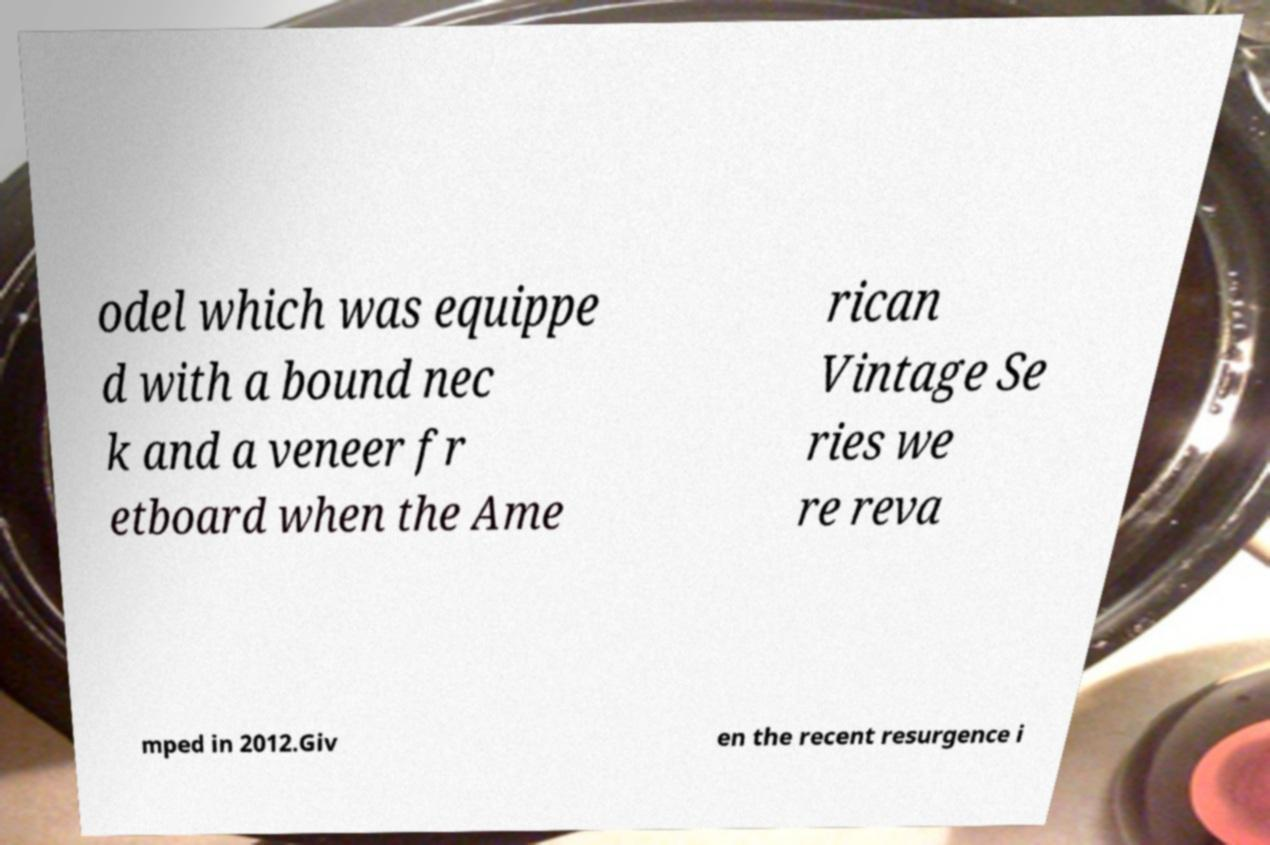Can you read and provide the text displayed in the image?This photo seems to have some interesting text. Can you extract and type it out for me? odel which was equippe d with a bound nec k and a veneer fr etboard when the Ame rican Vintage Se ries we re reva mped in 2012.Giv en the recent resurgence i 